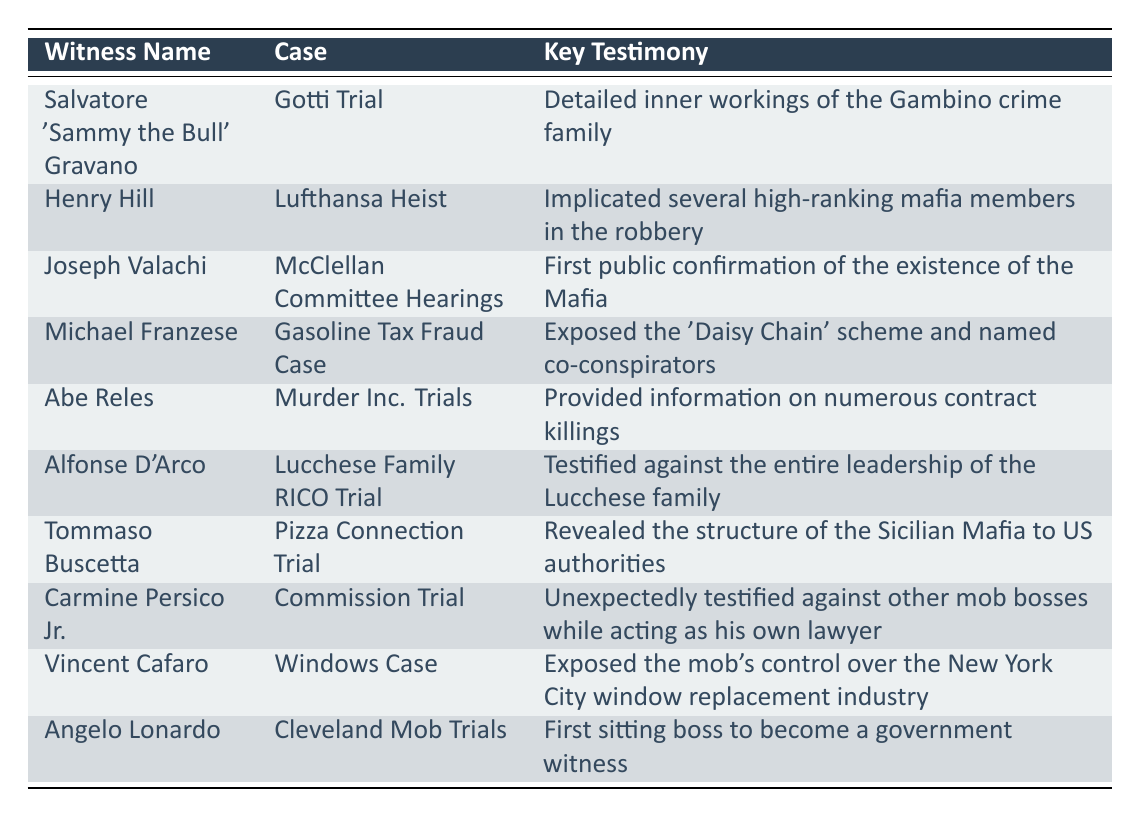What was the key testimony provided by Salvatore 'Sammy the Bull' Gravano in the Gotti Trial? The table shows that Salvatore 'Sammy the Bull' Gravano provided detailed information about the inner workings of the Gambino crime family during the Gotti Trial.
Answer: Detailed inner workings of the Gambino crime family Which witness testified against all members of the Lucchese family? According to the table, Alfonse D'Arco testified against the entire leadership of the Lucchese family in the Lucchese Family RICO Trial.
Answer: Alfonse D'Arco How many witnesses testified in high-profile cases involving the Mafia? The table lists ten witnesses who provided testimonies in various high-profile cases, thereby indicating that the total number of witnesses is 10.
Answer: 10 Did Tommaso Buscetta provide any information about the Sicilian Mafia? Yes, the table indicates that Tommaso Buscetta revealed the structure of the Sicilian Mafia to U.S. authorities during the Pizza Connection Trial.
Answer: Yes What was the average number of key testimonies per case based on the provided data? There are 10 key testimonies and 8 unique cases (Gotti Trial, Lufthansa Heist, McClellan Committee Hearings, Gasoline Tax Fraud Case, Murder Inc. Trials, Lucchese Family RICO Trial, Pizza Connection Trial, Commission Trial, Windows Case, and Cleveland Mob Trials).  Thus, the average is roughly 1.25 testimonies per case.
Answer: 1.25 Which witness was the first sitting boss to become a government witness? The table states that Angelo Lonardo was the first sitting boss to become a government witness during the Cleveland Mob Trials.
Answer: Angelo Lonardo Did Carmine Persico Jr. testify while acting as his own lawyer? Yes, the table confirms that Carmine Persico Jr. unexpectedly testified against other mob bosses while representing himself during the Commission Trial.
Answer: Yes What is the key testimony associated with the Lufthansa Heist case? The key testimony for the Lufthansa Heist case, as indicated in the table, is that Henry Hill implicated several high-ranking mafia members in the robbery.
Answer: Implicated several high-ranking mafia members in the robbery 